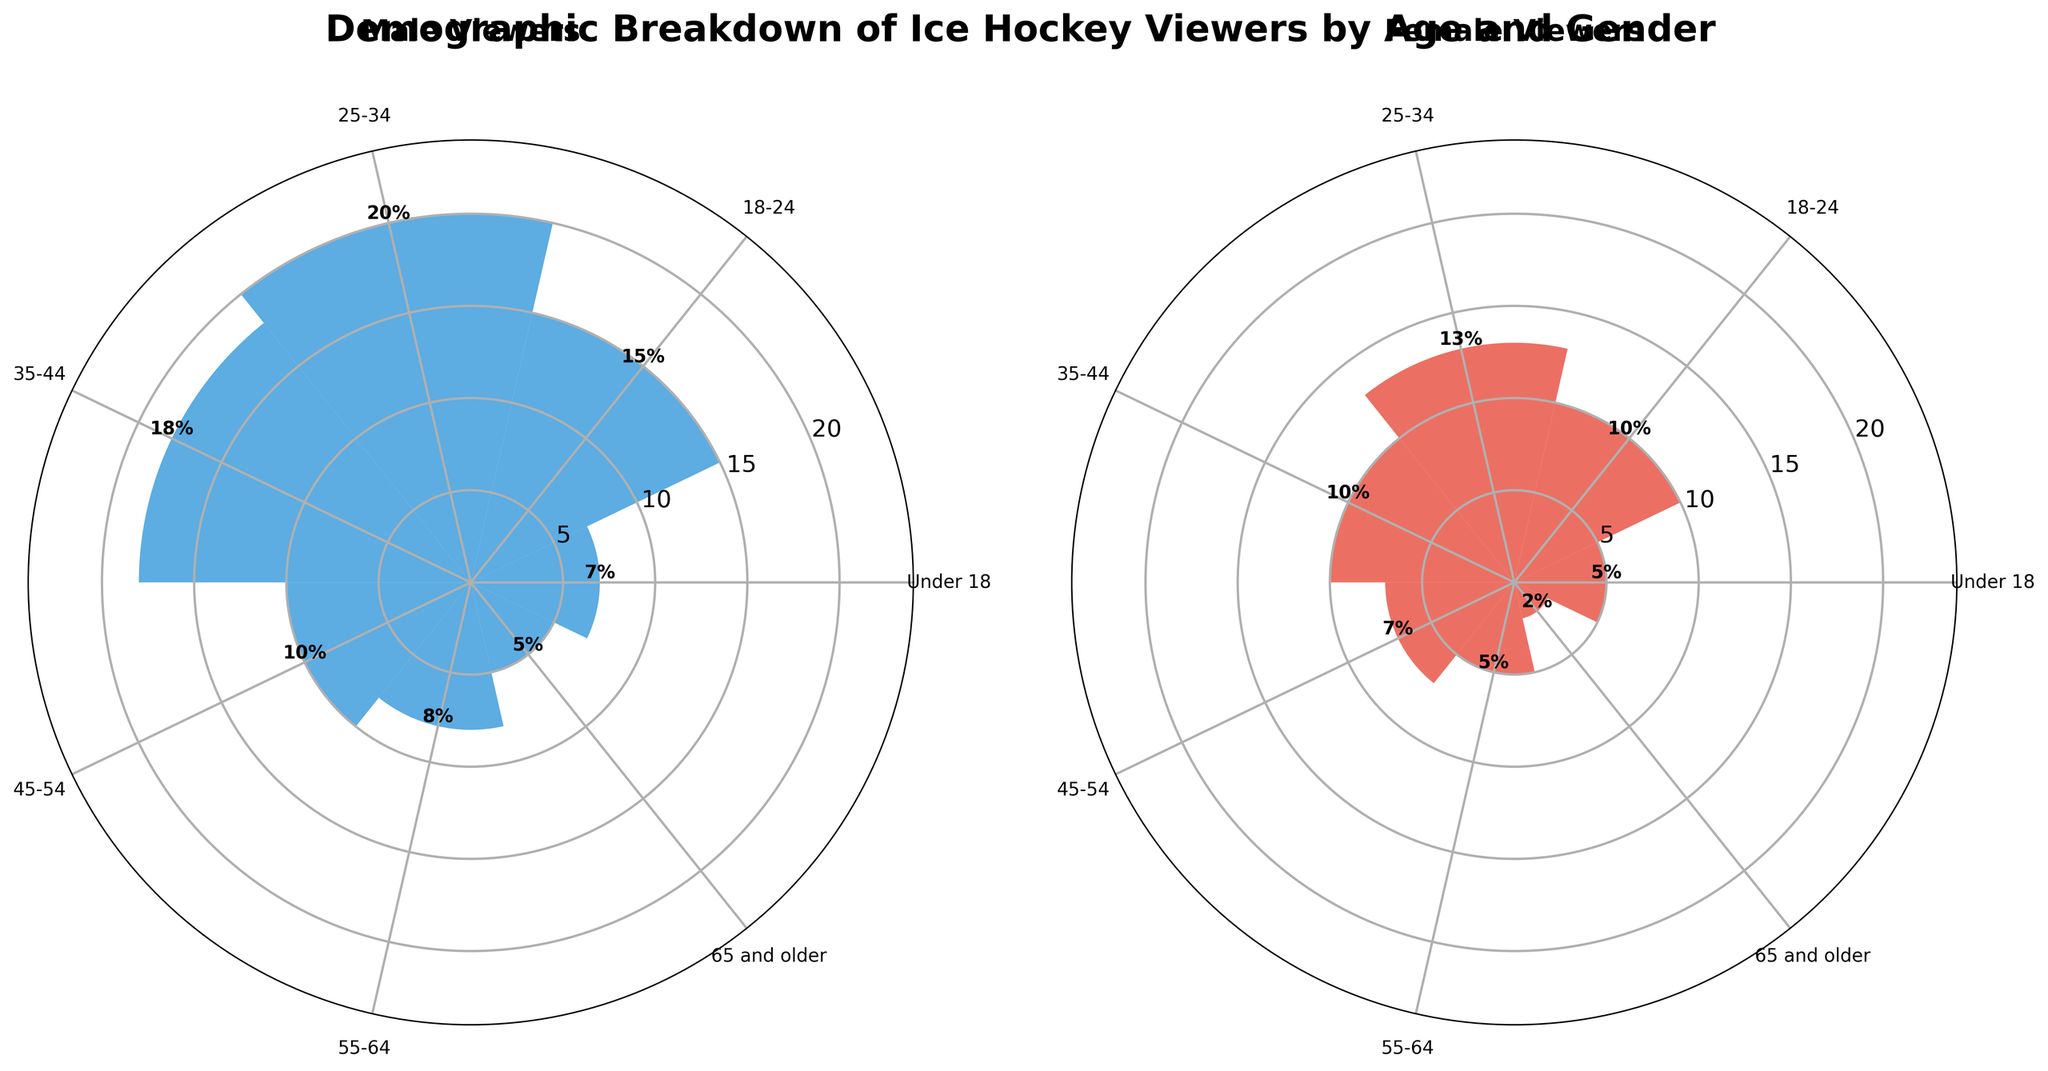What's the title of the figure? The title is the largest text, usually centered at the top of the figure. It reads "Demographic Breakdown of Ice Hockey Viewers by Age and Gender".
Answer: Demographic Breakdown of Ice Hockey Viewers by Age and Gender What age group has the highest percentage of male viewers? Look at the Male Viewers rose chart and compare the heights of the bars. The tallest bar corresponds to the 25-34 age group.
Answer: 25-34 What is the difference in percentage between male and female viewers in the 25-34 age group? Find the percentage values for the 25-34 age group in both the male and female charts. For males, it is 20%, and for females, it is 13%. Subtract the female percentage from the male percentage: 20% - 13% = 7%.
Answer: 7% Which age group has the smallest percentage of female viewers? Look at the Female Viewers rose chart and identify the shortest bar. It corresponds to the age group 65 and older.
Answer: 65 and older How does the percentage of viewers aged 18-24 compare between males and females? Check the bars for the 18-24 age group in both charts. The male percentage is 15%, and the female percentage is 10%. Compare them to see that males have a higher percentage.
Answer: Males have a higher percentage What is the combined percentage of viewers aged 35-44 (both males and females)? Find the percentages for the 35-44 age group in both charts. For males, it is 18%, and for females, it is 10%. Add these percentages together: 18% + 10% = 28%.
Answer: 28% Which gender has a wider range of percentage values across all age groups? Compare the range of values in both charts. The range for males is from 5% to 20%, while for females, it is from 2% to 13%. Males have a wider range.
Answer: Males What's the total sum of percentages for all male viewers across all age groups? Sum the percentages for all the age groups in the Male Viewers chart: 7% + 15% + 20% + 18% + 10% + 8% + 5% = 83%.
Answer: 83% For what age group(s) is the percentage of female viewers exactly half of the percentage of male viewers? Compare the percentages in both charts. For the 55-64 age group, males have 8%, and females have 4% (half of 8%).
Answer: 55-64 Which age group has the smallest percentage difference between male and female viewers? Calculate the difference for each age group: Under 18 (2%), 18-24 (5%), 25-34 (7%), 35-44 (8%), 45-54 (3%), 55-64 (3%), 65 and older (3%). The smallest differences are all 3%.
Answer: 45-54, 55-64, 65 and older 